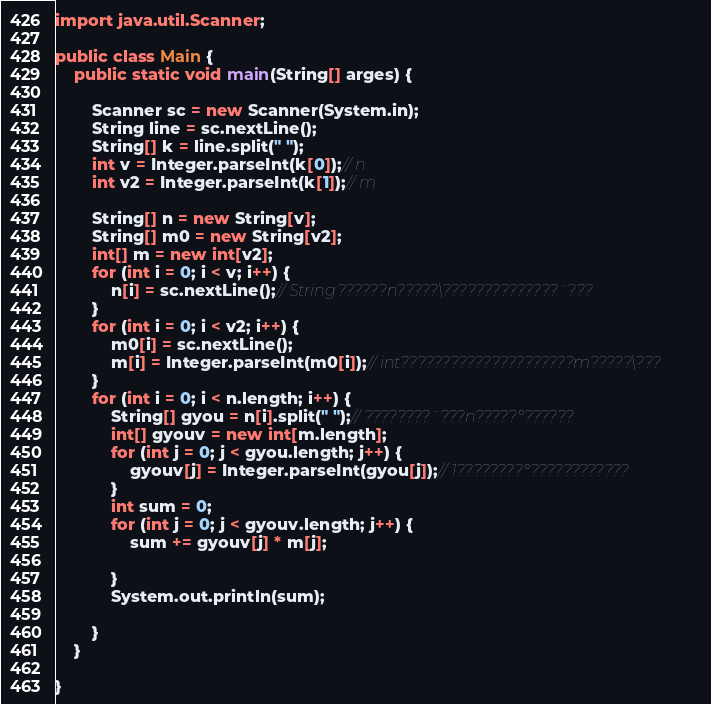Convert code to text. <code><loc_0><loc_0><loc_500><loc_500><_Java_>import java.util.Scanner;

public class Main {
	public static void main(String[] arges) {

		Scanner sc = new Scanner(System.in);
		String line = sc.nextLine();
		String[] k = line.split(" ");
		int v = Integer.parseInt(k[0]);// n
		int v2 = Integer.parseInt(k[1]);// m

		String[] n = new String[v];
		String[] m0 = new String[v2];
		int[] m = new int[v2];
		for (int i = 0; i < v; i++) {
			n[i] = sc.nextLine();// String??????n?????\??????????????¨???
		}
		for (int i = 0; i < v2; i++) {
			m0[i] = sc.nextLine();
			m[i] = Integer.parseInt(m0[i]);// int?????????????????????m?????\???
		}
		for (int i = 0; i < n.length; i++) {
			String[] gyou = n[i].split(" ");// ????????¨???n?????°??????
			int[] gyouv = new int[m.length];
			for (int j = 0; j < gyou.length; j++) {
				gyouv[j] = Integer.parseInt(gyou[j]);// 1????????°????????????
			}
			int sum = 0;
			for (int j = 0; j < gyouv.length; j++) {
				sum += gyouv[j] * m[j];

			}
			System.out.println(sum);

		}
	}

}</code> 